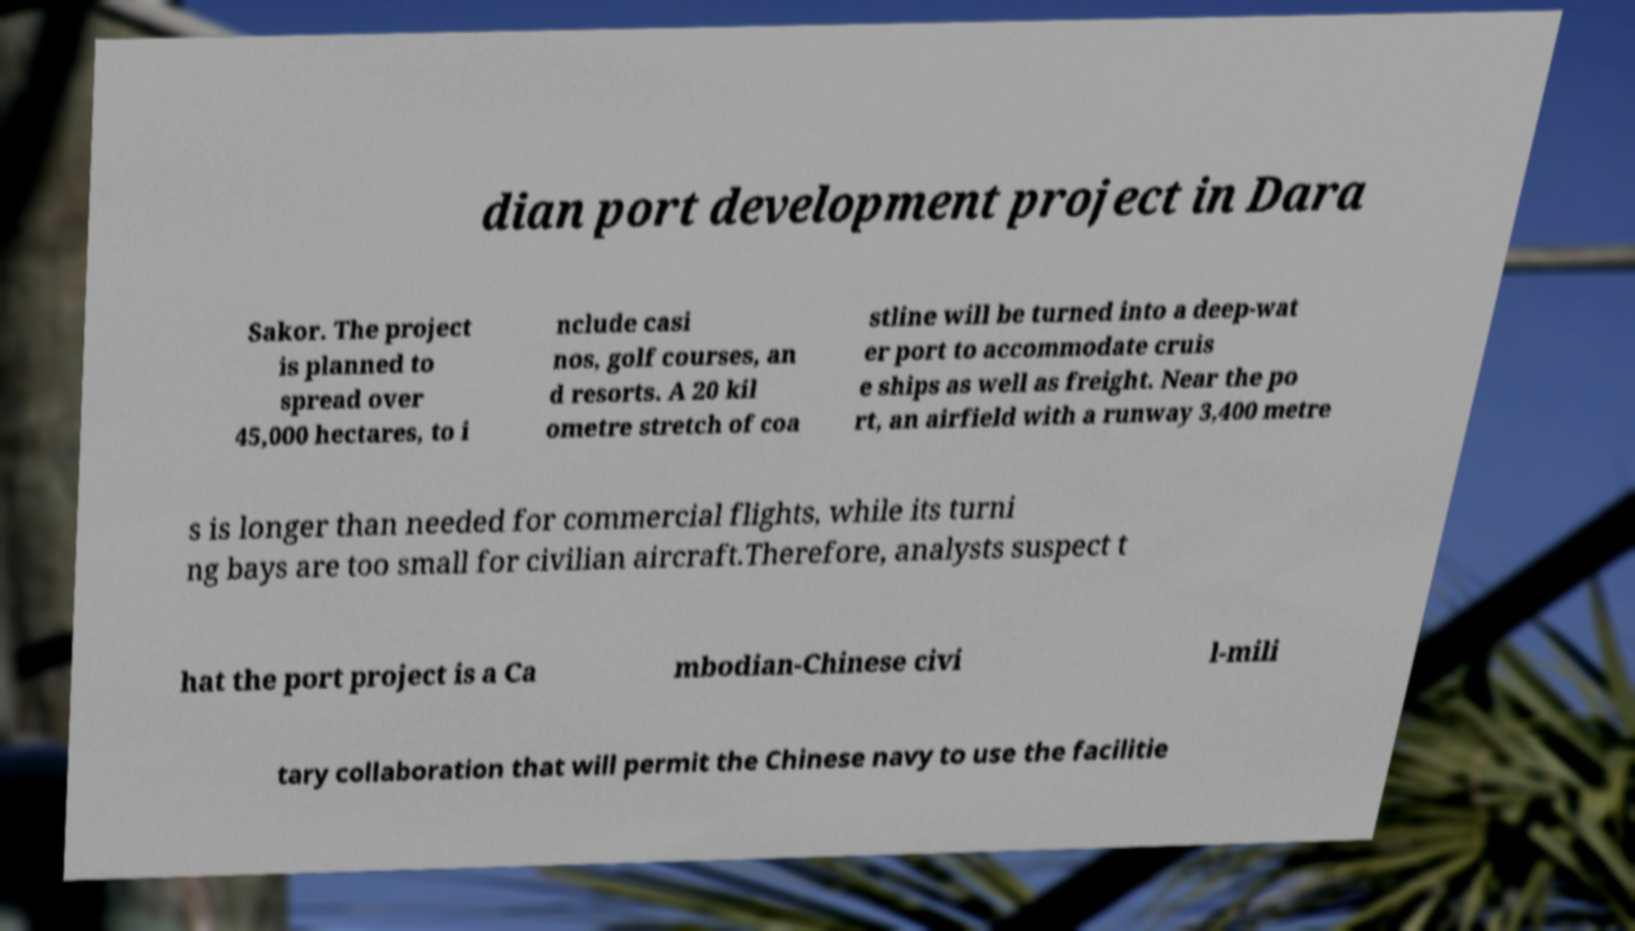Please identify and transcribe the text found in this image. dian port development project in Dara Sakor. The project is planned to spread over 45,000 hectares, to i nclude casi nos, golf courses, an d resorts. A 20 kil ometre stretch of coa stline will be turned into a deep-wat er port to accommodate cruis e ships as well as freight. Near the po rt, an airfield with a runway 3,400 metre s is longer than needed for commercial flights, while its turni ng bays are too small for civilian aircraft.Therefore, analysts suspect t hat the port project is a Ca mbodian-Chinese civi l-mili tary collaboration that will permit the Chinese navy to use the facilitie 